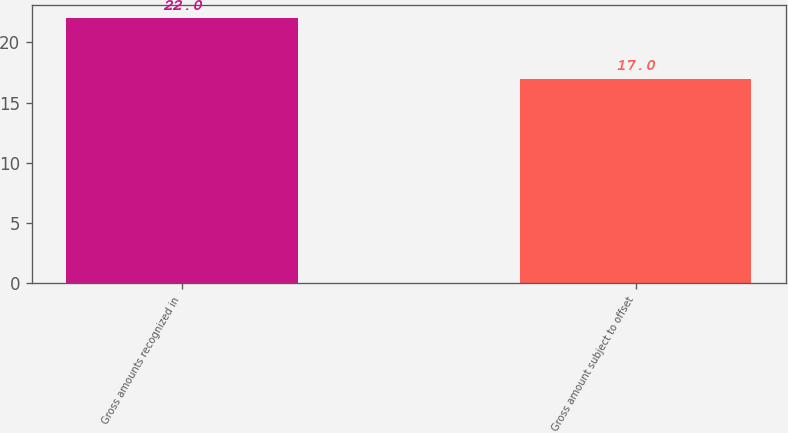Convert chart to OTSL. <chart><loc_0><loc_0><loc_500><loc_500><bar_chart><fcel>Gross amounts recognized in<fcel>Gross amount subject to offset<nl><fcel>22<fcel>17<nl></chart> 